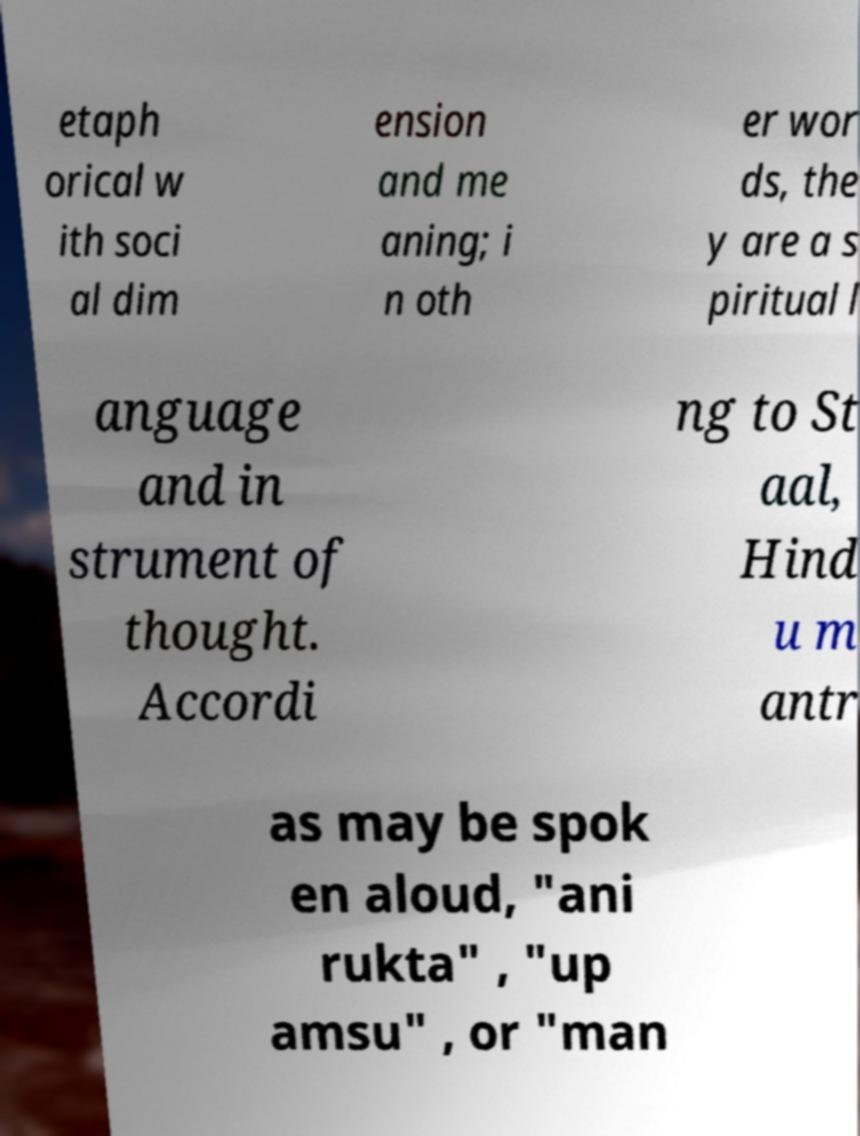There's text embedded in this image that I need extracted. Can you transcribe it verbatim? etaph orical w ith soci al dim ension and me aning; i n oth er wor ds, the y are a s piritual l anguage and in strument of thought. Accordi ng to St aal, Hind u m antr as may be spok en aloud, "ani rukta" , "up amsu" , or "man 